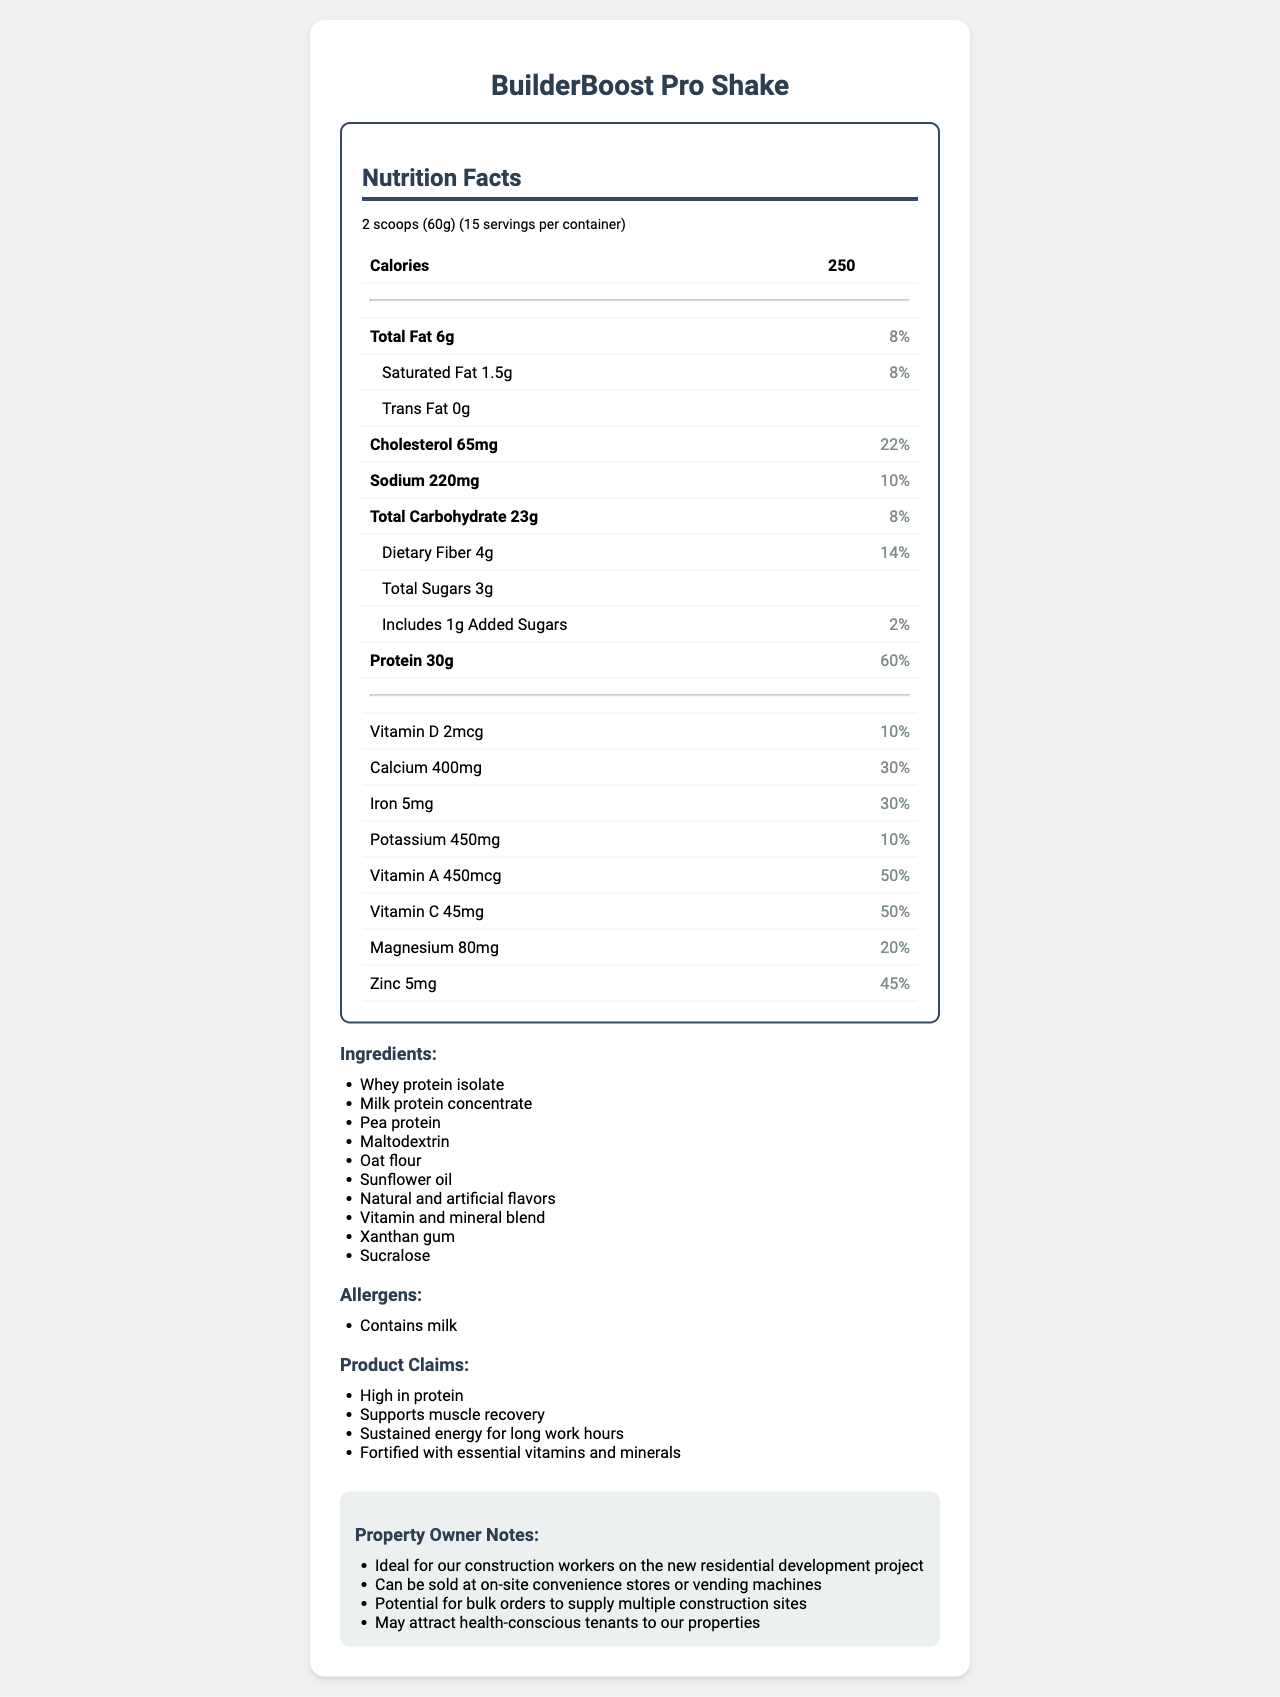what is the serving size of BuilderBoost Pro Shake? The serving size is explicitly listed as "2 scoops (60g)" under the Nutrition Facts heading in the document.
Answer: 2 scoops (60g) how many servings are there per container? The document states that there are 15 servings per container directly under the serving size information.
Answer: 15 what is the total amount of fat per serving? In the nutrition facts table, it states that there are 6 grams of total fat per serving.
Answer: 6g what percentage of the daily value of cholesterol does one serving provide? The cholesterol information shows 65mg with a daily value of 22%.
Answer: 22% how many grams of protein are in one serving? The protein amount per serving is listed as 30 grams.
Answer: 30g which vitamin contributes 50% of the daily value per serving? A. Vitamin D B. Vitamin A C. Vitamin C D. Vitamin E Both Vitamin A and Vitamin C offer 50% of the daily value. However, since the options only allow for one correct choice, Vitamin A (Option B) should be chosen.
Answer: B which of the following ingredients is not present in BuilderBoost Pro Shake? A. Whey protein isolate B. Soy protein C. Pea protein D. Xanthan gum The ingredients list includes whey protein isolate, pea protein, and xanthan gum, but does not include soy protein.
Answer: B does the BuilderBoost Pro Shake contain any allergens? The allergens section lists that the shake contains milk.
Answer: Yes is the BuilderBoost Pro Shake marketed as high in protein? One of the marketing claims is explicitly "High in protein."
Answer: Yes describe the main idea of the document. The explanation involves summarizing the various sections of the document, noting key pieces of information such as its nutritional value, targeted user base, and utility.
Answer: The document presents the nutrition facts of the BuilderBoost Pro Shake, a high-protein meal replacement specifically designed for construction workers. It details the serving size, nutritional content, vitamins, and minerals along with the ingredients, allergens, and marketing claims. There are also notes for property owners about potential sales and usage. what is the percentage of daily value supplied by magnesium? The document lists that magnesium contributes 80mg, which is 20% of the daily value.
Answer: 20% how much dietary fiber does one serving contain? The document specifies that there is 4 grams of dietary fiber per serving.
Answer: 4g can this shake be used for muscle recovery? One of the marketing claims includes "Supports muscle recovery."
Answer: Yes which mineral provides both iron and zinc in the BuilderBoost Pro Shake? The document lists the amounts and daily values of iron and zinc separately and does not provide information on a single mineral providing both.
Answer: Cannot be determined how many calories are in a serving of BuilderBoost Pro Shake? The document clearly states that each serving contains 250 calories.
Answer: 250 